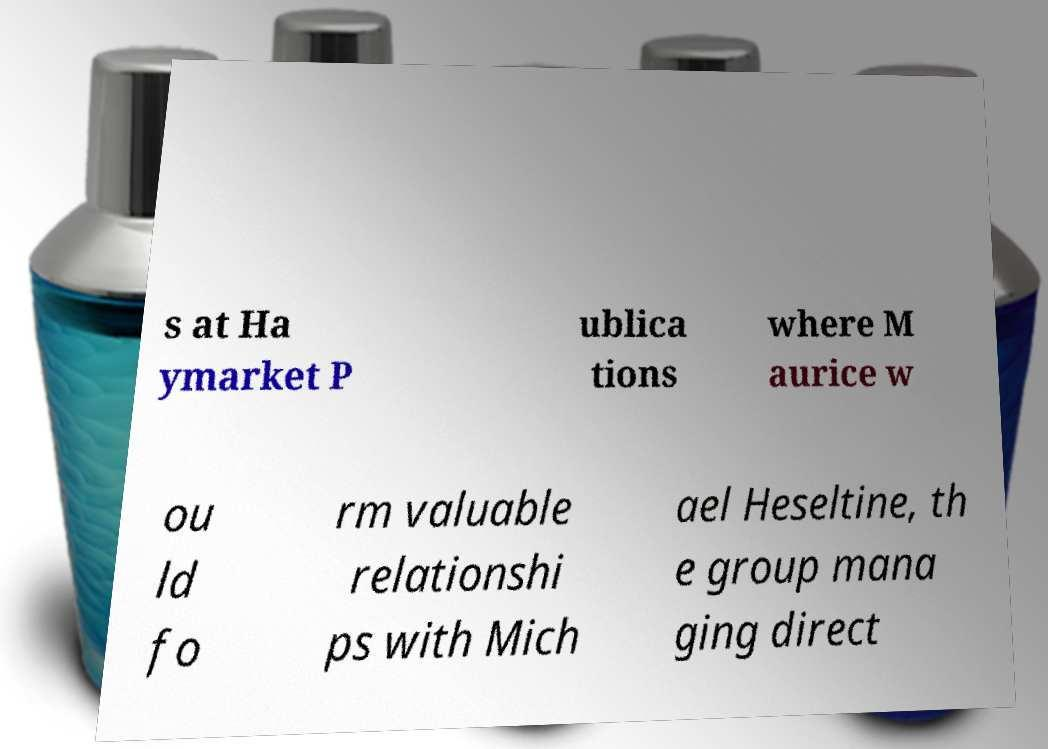For documentation purposes, I need the text within this image transcribed. Could you provide that? s at Ha ymarket P ublica tions where M aurice w ou ld fo rm valuable relationshi ps with Mich ael Heseltine, th e group mana ging direct 